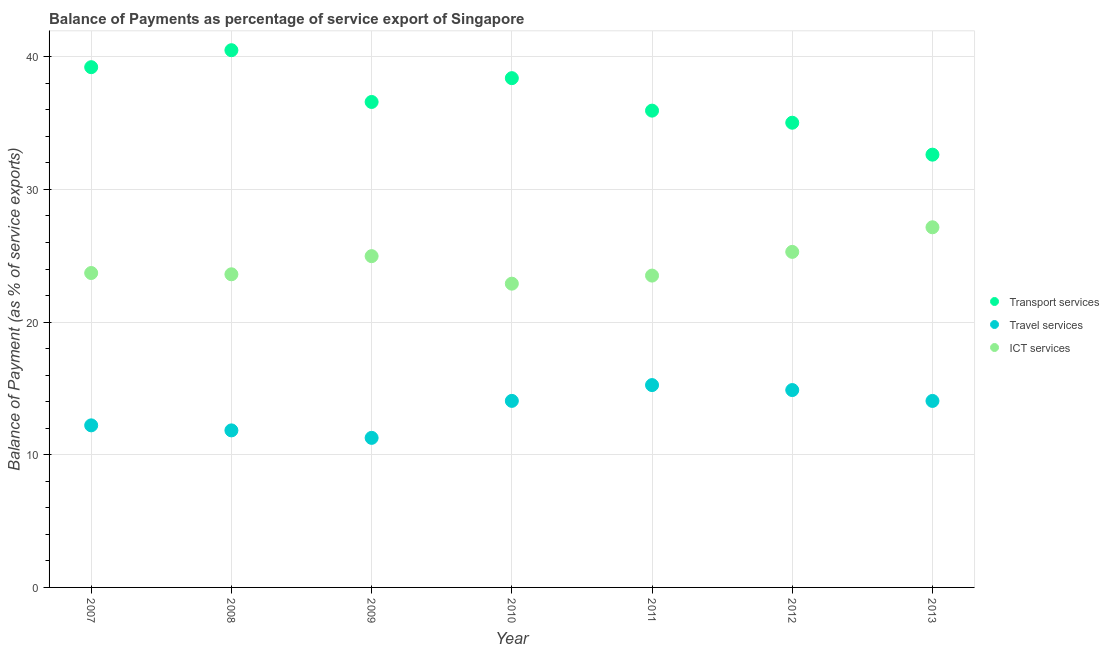How many different coloured dotlines are there?
Offer a terse response. 3. What is the balance of payment of travel services in 2010?
Provide a short and direct response. 14.06. Across all years, what is the maximum balance of payment of transport services?
Offer a very short reply. 40.49. Across all years, what is the minimum balance of payment of transport services?
Provide a succinct answer. 32.62. In which year was the balance of payment of travel services maximum?
Your answer should be very brief. 2011. What is the total balance of payment of travel services in the graph?
Your answer should be very brief. 93.57. What is the difference between the balance of payment of ict services in 2007 and that in 2013?
Provide a succinct answer. -3.45. What is the difference between the balance of payment of travel services in 2007 and the balance of payment of transport services in 2012?
Offer a terse response. -22.81. What is the average balance of payment of travel services per year?
Give a very brief answer. 13.37. In the year 2007, what is the difference between the balance of payment of transport services and balance of payment of ict services?
Provide a succinct answer. 15.52. What is the ratio of the balance of payment of travel services in 2007 to that in 2008?
Keep it short and to the point. 1.03. What is the difference between the highest and the second highest balance of payment of travel services?
Provide a short and direct response. 0.38. What is the difference between the highest and the lowest balance of payment of travel services?
Offer a terse response. 3.98. In how many years, is the balance of payment of ict services greater than the average balance of payment of ict services taken over all years?
Provide a short and direct response. 3. Is the sum of the balance of payment of transport services in 2007 and 2013 greater than the maximum balance of payment of travel services across all years?
Your response must be concise. Yes. Is the balance of payment of travel services strictly greater than the balance of payment of transport services over the years?
Keep it short and to the point. No. How many dotlines are there?
Your answer should be very brief. 3. Are the values on the major ticks of Y-axis written in scientific E-notation?
Give a very brief answer. No. Does the graph contain grids?
Ensure brevity in your answer.  Yes. How many legend labels are there?
Keep it short and to the point. 3. How are the legend labels stacked?
Offer a terse response. Vertical. What is the title of the graph?
Provide a succinct answer. Balance of Payments as percentage of service export of Singapore. What is the label or title of the Y-axis?
Ensure brevity in your answer.  Balance of Payment (as % of service exports). What is the Balance of Payment (as % of service exports) in Transport services in 2007?
Keep it short and to the point. 39.21. What is the Balance of Payment (as % of service exports) of Travel services in 2007?
Provide a succinct answer. 12.22. What is the Balance of Payment (as % of service exports) of ICT services in 2007?
Your response must be concise. 23.7. What is the Balance of Payment (as % of service exports) of Transport services in 2008?
Your answer should be compact. 40.49. What is the Balance of Payment (as % of service exports) in Travel services in 2008?
Offer a very short reply. 11.84. What is the Balance of Payment (as % of service exports) in ICT services in 2008?
Provide a succinct answer. 23.6. What is the Balance of Payment (as % of service exports) of Transport services in 2009?
Keep it short and to the point. 36.59. What is the Balance of Payment (as % of service exports) in Travel services in 2009?
Provide a short and direct response. 11.27. What is the Balance of Payment (as % of service exports) in ICT services in 2009?
Provide a short and direct response. 24.97. What is the Balance of Payment (as % of service exports) of Transport services in 2010?
Your answer should be very brief. 38.39. What is the Balance of Payment (as % of service exports) in Travel services in 2010?
Your answer should be compact. 14.06. What is the Balance of Payment (as % of service exports) in ICT services in 2010?
Provide a short and direct response. 22.9. What is the Balance of Payment (as % of service exports) of Transport services in 2011?
Your response must be concise. 35.94. What is the Balance of Payment (as % of service exports) of Travel services in 2011?
Offer a terse response. 15.25. What is the Balance of Payment (as % of service exports) in ICT services in 2011?
Provide a succinct answer. 23.5. What is the Balance of Payment (as % of service exports) of Transport services in 2012?
Your answer should be compact. 35.03. What is the Balance of Payment (as % of service exports) of Travel services in 2012?
Provide a short and direct response. 14.88. What is the Balance of Payment (as % of service exports) of ICT services in 2012?
Your response must be concise. 25.29. What is the Balance of Payment (as % of service exports) in Transport services in 2013?
Ensure brevity in your answer.  32.62. What is the Balance of Payment (as % of service exports) in Travel services in 2013?
Provide a short and direct response. 14.06. What is the Balance of Payment (as % of service exports) in ICT services in 2013?
Make the answer very short. 27.15. Across all years, what is the maximum Balance of Payment (as % of service exports) in Transport services?
Keep it short and to the point. 40.49. Across all years, what is the maximum Balance of Payment (as % of service exports) of Travel services?
Provide a succinct answer. 15.25. Across all years, what is the maximum Balance of Payment (as % of service exports) of ICT services?
Keep it short and to the point. 27.15. Across all years, what is the minimum Balance of Payment (as % of service exports) of Transport services?
Provide a succinct answer. 32.62. Across all years, what is the minimum Balance of Payment (as % of service exports) in Travel services?
Your response must be concise. 11.27. Across all years, what is the minimum Balance of Payment (as % of service exports) in ICT services?
Offer a very short reply. 22.9. What is the total Balance of Payment (as % of service exports) in Transport services in the graph?
Provide a succinct answer. 258.27. What is the total Balance of Payment (as % of service exports) in Travel services in the graph?
Make the answer very short. 93.57. What is the total Balance of Payment (as % of service exports) of ICT services in the graph?
Offer a very short reply. 171.11. What is the difference between the Balance of Payment (as % of service exports) of Transport services in 2007 and that in 2008?
Provide a short and direct response. -1.28. What is the difference between the Balance of Payment (as % of service exports) of Travel services in 2007 and that in 2008?
Keep it short and to the point. 0.38. What is the difference between the Balance of Payment (as % of service exports) of ICT services in 2007 and that in 2008?
Your response must be concise. 0.1. What is the difference between the Balance of Payment (as % of service exports) of Transport services in 2007 and that in 2009?
Your answer should be very brief. 2.62. What is the difference between the Balance of Payment (as % of service exports) in Travel services in 2007 and that in 2009?
Ensure brevity in your answer.  0.94. What is the difference between the Balance of Payment (as % of service exports) in ICT services in 2007 and that in 2009?
Offer a terse response. -1.27. What is the difference between the Balance of Payment (as % of service exports) of Transport services in 2007 and that in 2010?
Your answer should be compact. 0.83. What is the difference between the Balance of Payment (as % of service exports) of Travel services in 2007 and that in 2010?
Offer a very short reply. -1.84. What is the difference between the Balance of Payment (as % of service exports) of ICT services in 2007 and that in 2010?
Provide a succinct answer. 0.8. What is the difference between the Balance of Payment (as % of service exports) of Transport services in 2007 and that in 2011?
Offer a terse response. 3.28. What is the difference between the Balance of Payment (as % of service exports) of Travel services in 2007 and that in 2011?
Offer a terse response. -3.04. What is the difference between the Balance of Payment (as % of service exports) of ICT services in 2007 and that in 2011?
Your answer should be very brief. 0.19. What is the difference between the Balance of Payment (as % of service exports) of Transport services in 2007 and that in 2012?
Offer a very short reply. 4.19. What is the difference between the Balance of Payment (as % of service exports) of Travel services in 2007 and that in 2012?
Provide a succinct answer. -2.66. What is the difference between the Balance of Payment (as % of service exports) in ICT services in 2007 and that in 2012?
Your answer should be very brief. -1.59. What is the difference between the Balance of Payment (as % of service exports) in Transport services in 2007 and that in 2013?
Your answer should be compact. 6.59. What is the difference between the Balance of Payment (as % of service exports) of Travel services in 2007 and that in 2013?
Provide a short and direct response. -1.84. What is the difference between the Balance of Payment (as % of service exports) of ICT services in 2007 and that in 2013?
Your response must be concise. -3.45. What is the difference between the Balance of Payment (as % of service exports) of Transport services in 2008 and that in 2009?
Ensure brevity in your answer.  3.9. What is the difference between the Balance of Payment (as % of service exports) in Travel services in 2008 and that in 2009?
Ensure brevity in your answer.  0.56. What is the difference between the Balance of Payment (as % of service exports) in ICT services in 2008 and that in 2009?
Your answer should be very brief. -1.37. What is the difference between the Balance of Payment (as % of service exports) in Transport services in 2008 and that in 2010?
Offer a terse response. 2.11. What is the difference between the Balance of Payment (as % of service exports) of Travel services in 2008 and that in 2010?
Give a very brief answer. -2.22. What is the difference between the Balance of Payment (as % of service exports) in ICT services in 2008 and that in 2010?
Keep it short and to the point. 0.71. What is the difference between the Balance of Payment (as % of service exports) in Transport services in 2008 and that in 2011?
Offer a terse response. 4.55. What is the difference between the Balance of Payment (as % of service exports) in Travel services in 2008 and that in 2011?
Ensure brevity in your answer.  -3.42. What is the difference between the Balance of Payment (as % of service exports) in ICT services in 2008 and that in 2011?
Your answer should be very brief. 0.1. What is the difference between the Balance of Payment (as % of service exports) in Transport services in 2008 and that in 2012?
Ensure brevity in your answer.  5.47. What is the difference between the Balance of Payment (as % of service exports) of Travel services in 2008 and that in 2012?
Make the answer very short. -3.04. What is the difference between the Balance of Payment (as % of service exports) in ICT services in 2008 and that in 2012?
Keep it short and to the point. -1.69. What is the difference between the Balance of Payment (as % of service exports) of Transport services in 2008 and that in 2013?
Provide a short and direct response. 7.87. What is the difference between the Balance of Payment (as % of service exports) of Travel services in 2008 and that in 2013?
Your answer should be compact. -2.22. What is the difference between the Balance of Payment (as % of service exports) of ICT services in 2008 and that in 2013?
Offer a terse response. -3.54. What is the difference between the Balance of Payment (as % of service exports) in Transport services in 2009 and that in 2010?
Give a very brief answer. -1.79. What is the difference between the Balance of Payment (as % of service exports) in Travel services in 2009 and that in 2010?
Provide a short and direct response. -2.79. What is the difference between the Balance of Payment (as % of service exports) of ICT services in 2009 and that in 2010?
Your answer should be compact. 2.07. What is the difference between the Balance of Payment (as % of service exports) of Transport services in 2009 and that in 2011?
Ensure brevity in your answer.  0.65. What is the difference between the Balance of Payment (as % of service exports) of Travel services in 2009 and that in 2011?
Keep it short and to the point. -3.98. What is the difference between the Balance of Payment (as % of service exports) of ICT services in 2009 and that in 2011?
Your answer should be very brief. 1.47. What is the difference between the Balance of Payment (as % of service exports) in Transport services in 2009 and that in 2012?
Your answer should be very brief. 1.57. What is the difference between the Balance of Payment (as % of service exports) in Travel services in 2009 and that in 2012?
Offer a terse response. -3.6. What is the difference between the Balance of Payment (as % of service exports) in ICT services in 2009 and that in 2012?
Keep it short and to the point. -0.32. What is the difference between the Balance of Payment (as % of service exports) in Transport services in 2009 and that in 2013?
Your answer should be very brief. 3.97. What is the difference between the Balance of Payment (as % of service exports) of Travel services in 2009 and that in 2013?
Offer a terse response. -2.78. What is the difference between the Balance of Payment (as % of service exports) of ICT services in 2009 and that in 2013?
Make the answer very short. -2.18. What is the difference between the Balance of Payment (as % of service exports) of Transport services in 2010 and that in 2011?
Give a very brief answer. 2.45. What is the difference between the Balance of Payment (as % of service exports) of Travel services in 2010 and that in 2011?
Keep it short and to the point. -1.19. What is the difference between the Balance of Payment (as % of service exports) in ICT services in 2010 and that in 2011?
Offer a very short reply. -0.61. What is the difference between the Balance of Payment (as % of service exports) of Transport services in 2010 and that in 2012?
Offer a very short reply. 3.36. What is the difference between the Balance of Payment (as % of service exports) of Travel services in 2010 and that in 2012?
Your answer should be very brief. -0.82. What is the difference between the Balance of Payment (as % of service exports) of ICT services in 2010 and that in 2012?
Make the answer very short. -2.4. What is the difference between the Balance of Payment (as % of service exports) in Transport services in 2010 and that in 2013?
Keep it short and to the point. 5.77. What is the difference between the Balance of Payment (as % of service exports) in Travel services in 2010 and that in 2013?
Your answer should be compact. 0. What is the difference between the Balance of Payment (as % of service exports) of ICT services in 2010 and that in 2013?
Give a very brief answer. -4.25. What is the difference between the Balance of Payment (as % of service exports) of Transport services in 2011 and that in 2012?
Offer a terse response. 0.91. What is the difference between the Balance of Payment (as % of service exports) in Travel services in 2011 and that in 2012?
Give a very brief answer. 0.38. What is the difference between the Balance of Payment (as % of service exports) in ICT services in 2011 and that in 2012?
Your response must be concise. -1.79. What is the difference between the Balance of Payment (as % of service exports) in Transport services in 2011 and that in 2013?
Your answer should be compact. 3.32. What is the difference between the Balance of Payment (as % of service exports) of Travel services in 2011 and that in 2013?
Your answer should be very brief. 1.19. What is the difference between the Balance of Payment (as % of service exports) in ICT services in 2011 and that in 2013?
Provide a succinct answer. -3.64. What is the difference between the Balance of Payment (as % of service exports) of Transport services in 2012 and that in 2013?
Provide a short and direct response. 2.41. What is the difference between the Balance of Payment (as % of service exports) in Travel services in 2012 and that in 2013?
Make the answer very short. 0.82. What is the difference between the Balance of Payment (as % of service exports) in ICT services in 2012 and that in 2013?
Offer a very short reply. -1.85. What is the difference between the Balance of Payment (as % of service exports) in Transport services in 2007 and the Balance of Payment (as % of service exports) in Travel services in 2008?
Offer a very short reply. 27.38. What is the difference between the Balance of Payment (as % of service exports) in Transport services in 2007 and the Balance of Payment (as % of service exports) in ICT services in 2008?
Make the answer very short. 15.61. What is the difference between the Balance of Payment (as % of service exports) of Travel services in 2007 and the Balance of Payment (as % of service exports) of ICT services in 2008?
Offer a very short reply. -11.39. What is the difference between the Balance of Payment (as % of service exports) of Transport services in 2007 and the Balance of Payment (as % of service exports) of Travel services in 2009?
Give a very brief answer. 27.94. What is the difference between the Balance of Payment (as % of service exports) in Transport services in 2007 and the Balance of Payment (as % of service exports) in ICT services in 2009?
Offer a terse response. 14.24. What is the difference between the Balance of Payment (as % of service exports) of Travel services in 2007 and the Balance of Payment (as % of service exports) of ICT services in 2009?
Provide a short and direct response. -12.75. What is the difference between the Balance of Payment (as % of service exports) of Transport services in 2007 and the Balance of Payment (as % of service exports) of Travel services in 2010?
Give a very brief answer. 25.15. What is the difference between the Balance of Payment (as % of service exports) in Transport services in 2007 and the Balance of Payment (as % of service exports) in ICT services in 2010?
Your response must be concise. 16.32. What is the difference between the Balance of Payment (as % of service exports) in Travel services in 2007 and the Balance of Payment (as % of service exports) in ICT services in 2010?
Give a very brief answer. -10.68. What is the difference between the Balance of Payment (as % of service exports) in Transport services in 2007 and the Balance of Payment (as % of service exports) in Travel services in 2011?
Your answer should be compact. 23.96. What is the difference between the Balance of Payment (as % of service exports) of Transport services in 2007 and the Balance of Payment (as % of service exports) of ICT services in 2011?
Your response must be concise. 15.71. What is the difference between the Balance of Payment (as % of service exports) of Travel services in 2007 and the Balance of Payment (as % of service exports) of ICT services in 2011?
Offer a terse response. -11.29. What is the difference between the Balance of Payment (as % of service exports) of Transport services in 2007 and the Balance of Payment (as % of service exports) of Travel services in 2012?
Keep it short and to the point. 24.34. What is the difference between the Balance of Payment (as % of service exports) of Transport services in 2007 and the Balance of Payment (as % of service exports) of ICT services in 2012?
Offer a terse response. 13.92. What is the difference between the Balance of Payment (as % of service exports) of Travel services in 2007 and the Balance of Payment (as % of service exports) of ICT services in 2012?
Your answer should be compact. -13.08. What is the difference between the Balance of Payment (as % of service exports) in Transport services in 2007 and the Balance of Payment (as % of service exports) in Travel services in 2013?
Give a very brief answer. 25.16. What is the difference between the Balance of Payment (as % of service exports) of Transport services in 2007 and the Balance of Payment (as % of service exports) of ICT services in 2013?
Your answer should be compact. 12.07. What is the difference between the Balance of Payment (as % of service exports) in Travel services in 2007 and the Balance of Payment (as % of service exports) in ICT services in 2013?
Ensure brevity in your answer.  -14.93. What is the difference between the Balance of Payment (as % of service exports) in Transport services in 2008 and the Balance of Payment (as % of service exports) in Travel services in 2009?
Your answer should be compact. 29.22. What is the difference between the Balance of Payment (as % of service exports) in Transport services in 2008 and the Balance of Payment (as % of service exports) in ICT services in 2009?
Your answer should be compact. 15.52. What is the difference between the Balance of Payment (as % of service exports) of Travel services in 2008 and the Balance of Payment (as % of service exports) of ICT services in 2009?
Your answer should be very brief. -13.13. What is the difference between the Balance of Payment (as % of service exports) of Transport services in 2008 and the Balance of Payment (as % of service exports) of Travel services in 2010?
Your answer should be compact. 26.43. What is the difference between the Balance of Payment (as % of service exports) of Transport services in 2008 and the Balance of Payment (as % of service exports) of ICT services in 2010?
Provide a short and direct response. 17.6. What is the difference between the Balance of Payment (as % of service exports) of Travel services in 2008 and the Balance of Payment (as % of service exports) of ICT services in 2010?
Keep it short and to the point. -11.06. What is the difference between the Balance of Payment (as % of service exports) in Transport services in 2008 and the Balance of Payment (as % of service exports) in Travel services in 2011?
Make the answer very short. 25.24. What is the difference between the Balance of Payment (as % of service exports) of Transport services in 2008 and the Balance of Payment (as % of service exports) of ICT services in 2011?
Keep it short and to the point. 16.99. What is the difference between the Balance of Payment (as % of service exports) of Travel services in 2008 and the Balance of Payment (as % of service exports) of ICT services in 2011?
Provide a short and direct response. -11.67. What is the difference between the Balance of Payment (as % of service exports) in Transport services in 2008 and the Balance of Payment (as % of service exports) in Travel services in 2012?
Provide a short and direct response. 25.62. What is the difference between the Balance of Payment (as % of service exports) of Transport services in 2008 and the Balance of Payment (as % of service exports) of ICT services in 2012?
Your answer should be compact. 15.2. What is the difference between the Balance of Payment (as % of service exports) in Travel services in 2008 and the Balance of Payment (as % of service exports) in ICT services in 2012?
Provide a short and direct response. -13.45. What is the difference between the Balance of Payment (as % of service exports) of Transport services in 2008 and the Balance of Payment (as % of service exports) of Travel services in 2013?
Provide a short and direct response. 26.44. What is the difference between the Balance of Payment (as % of service exports) in Transport services in 2008 and the Balance of Payment (as % of service exports) in ICT services in 2013?
Offer a terse response. 13.35. What is the difference between the Balance of Payment (as % of service exports) of Travel services in 2008 and the Balance of Payment (as % of service exports) of ICT services in 2013?
Keep it short and to the point. -15.31. What is the difference between the Balance of Payment (as % of service exports) of Transport services in 2009 and the Balance of Payment (as % of service exports) of Travel services in 2010?
Offer a very short reply. 22.53. What is the difference between the Balance of Payment (as % of service exports) in Transport services in 2009 and the Balance of Payment (as % of service exports) in ICT services in 2010?
Keep it short and to the point. 13.7. What is the difference between the Balance of Payment (as % of service exports) of Travel services in 2009 and the Balance of Payment (as % of service exports) of ICT services in 2010?
Provide a succinct answer. -11.62. What is the difference between the Balance of Payment (as % of service exports) of Transport services in 2009 and the Balance of Payment (as % of service exports) of Travel services in 2011?
Ensure brevity in your answer.  21.34. What is the difference between the Balance of Payment (as % of service exports) in Transport services in 2009 and the Balance of Payment (as % of service exports) in ICT services in 2011?
Your answer should be compact. 13.09. What is the difference between the Balance of Payment (as % of service exports) of Travel services in 2009 and the Balance of Payment (as % of service exports) of ICT services in 2011?
Give a very brief answer. -12.23. What is the difference between the Balance of Payment (as % of service exports) of Transport services in 2009 and the Balance of Payment (as % of service exports) of Travel services in 2012?
Ensure brevity in your answer.  21.72. What is the difference between the Balance of Payment (as % of service exports) of Transport services in 2009 and the Balance of Payment (as % of service exports) of ICT services in 2012?
Your answer should be very brief. 11.3. What is the difference between the Balance of Payment (as % of service exports) in Travel services in 2009 and the Balance of Payment (as % of service exports) in ICT services in 2012?
Offer a terse response. -14.02. What is the difference between the Balance of Payment (as % of service exports) in Transport services in 2009 and the Balance of Payment (as % of service exports) in Travel services in 2013?
Offer a very short reply. 22.53. What is the difference between the Balance of Payment (as % of service exports) in Transport services in 2009 and the Balance of Payment (as % of service exports) in ICT services in 2013?
Your response must be concise. 9.45. What is the difference between the Balance of Payment (as % of service exports) in Travel services in 2009 and the Balance of Payment (as % of service exports) in ICT services in 2013?
Offer a terse response. -15.87. What is the difference between the Balance of Payment (as % of service exports) in Transport services in 2010 and the Balance of Payment (as % of service exports) in Travel services in 2011?
Provide a succinct answer. 23.13. What is the difference between the Balance of Payment (as % of service exports) of Transport services in 2010 and the Balance of Payment (as % of service exports) of ICT services in 2011?
Your response must be concise. 14.88. What is the difference between the Balance of Payment (as % of service exports) of Travel services in 2010 and the Balance of Payment (as % of service exports) of ICT services in 2011?
Your answer should be very brief. -9.44. What is the difference between the Balance of Payment (as % of service exports) in Transport services in 2010 and the Balance of Payment (as % of service exports) in Travel services in 2012?
Your answer should be very brief. 23.51. What is the difference between the Balance of Payment (as % of service exports) of Transport services in 2010 and the Balance of Payment (as % of service exports) of ICT services in 2012?
Make the answer very short. 13.09. What is the difference between the Balance of Payment (as % of service exports) of Travel services in 2010 and the Balance of Payment (as % of service exports) of ICT services in 2012?
Provide a short and direct response. -11.23. What is the difference between the Balance of Payment (as % of service exports) of Transport services in 2010 and the Balance of Payment (as % of service exports) of Travel services in 2013?
Ensure brevity in your answer.  24.33. What is the difference between the Balance of Payment (as % of service exports) in Transport services in 2010 and the Balance of Payment (as % of service exports) in ICT services in 2013?
Provide a short and direct response. 11.24. What is the difference between the Balance of Payment (as % of service exports) in Travel services in 2010 and the Balance of Payment (as % of service exports) in ICT services in 2013?
Ensure brevity in your answer.  -13.09. What is the difference between the Balance of Payment (as % of service exports) of Transport services in 2011 and the Balance of Payment (as % of service exports) of Travel services in 2012?
Give a very brief answer. 21.06. What is the difference between the Balance of Payment (as % of service exports) of Transport services in 2011 and the Balance of Payment (as % of service exports) of ICT services in 2012?
Offer a terse response. 10.65. What is the difference between the Balance of Payment (as % of service exports) of Travel services in 2011 and the Balance of Payment (as % of service exports) of ICT services in 2012?
Your answer should be very brief. -10.04. What is the difference between the Balance of Payment (as % of service exports) of Transport services in 2011 and the Balance of Payment (as % of service exports) of Travel services in 2013?
Provide a short and direct response. 21.88. What is the difference between the Balance of Payment (as % of service exports) in Transport services in 2011 and the Balance of Payment (as % of service exports) in ICT services in 2013?
Your response must be concise. 8.79. What is the difference between the Balance of Payment (as % of service exports) of Travel services in 2011 and the Balance of Payment (as % of service exports) of ICT services in 2013?
Make the answer very short. -11.89. What is the difference between the Balance of Payment (as % of service exports) of Transport services in 2012 and the Balance of Payment (as % of service exports) of Travel services in 2013?
Provide a succinct answer. 20.97. What is the difference between the Balance of Payment (as % of service exports) of Transport services in 2012 and the Balance of Payment (as % of service exports) of ICT services in 2013?
Provide a succinct answer. 7.88. What is the difference between the Balance of Payment (as % of service exports) of Travel services in 2012 and the Balance of Payment (as % of service exports) of ICT services in 2013?
Ensure brevity in your answer.  -12.27. What is the average Balance of Payment (as % of service exports) of Transport services per year?
Your response must be concise. 36.9. What is the average Balance of Payment (as % of service exports) of Travel services per year?
Offer a very short reply. 13.37. What is the average Balance of Payment (as % of service exports) in ICT services per year?
Offer a very short reply. 24.44. In the year 2007, what is the difference between the Balance of Payment (as % of service exports) in Transport services and Balance of Payment (as % of service exports) in Travel services?
Provide a short and direct response. 27. In the year 2007, what is the difference between the Balance of Payment (as % of service exports) in Transport services and Balance of Payment (as % of service exports) in ICT services?
Ensure brevity in your answer.  15.52. In the year 2007, what is the difference between the Balance of Payment (as % of service exports) in Travel services and Balance of Payment (as % of service exports) in ICT services?
Provide a succinct answer. -11.48. In the year 2008, what is the difference between the Balance of Payment (as % of service exports) in Transport services and Balance of Payment (as % of service exports) in Travel services?
Keep it short and to the point. 28.66. In the year 2008, what is the difference between the Balance of Payment (as % of service exports) of Transport services and Balance of Payment (as % of service exports) of ICT services?
Make the answer very short. 16.89. In the year 2008, what is the difference between the Balance of Payment (as % of service exports) of Travel services and Balance of Payment (as % of service exports) of ICT services?
Your answer should be very brief. -11.77. In the year 2009, what is the difference between the Balance of Payment (as % of service exports) of Transport services and Balance of Payment (as % of service exports) of Travel services?
Offer a terse response. 25.32. In the year 2009, what is the difference between the Balance of Payment (as % of service exports) in Transport services and Balance of Payment (as % of service exports) in ICT services?
Provide a short and direct response. 11.62. In the year 2009, what is the difference between the Balance of Payment (as % of service exports) in Travel services and Balance of Payment (as % of service exports) in ICT services?
Your response must be concise. -13.7. In the year 2010, what is the difference between the Balance of Payment (as % of service exports) of Transport services and Balance of Payment (as % of service exports) of Travel services?
Your answer should be compact. 24.33. In the year 2010, what is the difference between the Balance of Payment (as % of service exports) in Transport services and Balance of Payment (as % of service exports) in ICT services?
Make the answer very short. 15.49. In the year 2010, what is the difference between the Balance of Payment (as % of service exports) of Travel services and Balance of Payment (as % of service exports) of ICT services?
Provide a short and direct response. -8.84. In the year 2011, what is the difference between the Balance of Payment (as % of service exports) of Transport services and Balance of Payment (as % of service exports) of Travel services?
Offer a very short reply. 20.69. In the year 2011, what is the difference between the Balance of Payment (as % of service exports) of Transport services and Balance of Payment (as % of service exports) of ICT services?
Offer a very short reply. 12.43. In the year 2011, what is the difference between the Balance of Payment (as % of service exports) of Travel services and Balance of Payment (as % of service exports) of ICT services?
Offer a terse response. -8.25. In the year 2012, what is the difference between the Balance of Payment (as % of service exports) in Transport services and Balance of Payment (as % of service exports) in Travel services?
Make the answer very short. 20.15. In the year 2012, what is the difference between the Balance of Payment (as % of service exports) of Transport services and Balance of Payment (as % of service exports) of ICT services?
Your answer should be very brief. 9.73. In the year 2012, what is the difference between the Balance of Payment (as % of service exports) of Travel services and Balance of Payment (as % of service exports) of ICT services?
Offer a very short reply. -10.42. In the year 2013, what is the difference between the Balance of Payment (as % of service exports) of Transport services and Balance of Payment (as % of service exports) of Travel services?
Make the answer very short. 18.56. In the year 2013, what is the difference between the Balance of Payment (as % of service exports) in Transport services and Balance of Payment (as % of service exports) in ICT services?
Ensure brevity in your answer.  5.47. In the year 2013, what is the difference between the Balance of Payment (as % of service exports) in Travel services and Balance of Payment (as % of service exports) in ICT services?
Provide a succinct answer. -13.09. What is the ratio of the Balance of Payment (as % of service exports) of Transport services in 2007 to that in 2008?
Provide a succinct answer. 0.97. What is the ratio of the Balance of Payment (as % of service exports) of Travel services in 2007 to that in 2008?
Your answer should be compact. 1.03. What is the ratio of the Balance of Payment (as % of service exports) in Transport services in 2007 to that in 2009?
Give a very brief answer. 1.07. What is the ratio of the Balance of Payment (as % of service exports) in Travel services in 2007 to that in 2009?
Ensure brevity in your answer.  1.08. What is the ratio of the Balance of Payment (as % of service exports) in ICT services in 2007 to that in 2009?
Offer a very short reply. 0.95. What is the ratio of the Balance of Payment (as % of service exports) in Transport services in 2007 to that in 2010?
Give a very brief answer. 1.02. What is the ratio of the Balance of Payment (as % of service exports) in Travel services in 2007 to that in 2010?
Keep it short and to the point. 0.87. What is the ratio of the Balance of Payment (as % of service exports) in ICT services in 2007 to that in 2010?
Offer a terse response. 1.04. What is the ratio of the Balance of Payment (as % of service exports) of Transport services in 2007 to that in 2011?
Provide a succinct answer. 1.09. What is the ratio of the Balance of Payment (as % of service exports) of Travel services in 2007 to that in 2011?
Make the answer very short. 0.8. What is the ratio of the Balance of Payment (as % of service exports) in ICT services in 2007 to that in 2011?
Make the answer very short. 1.01. What is the ratio of the Balance of Payment (as % of service exports) of Transport services in 2007 to that in 2012?
Offer a terse response. 1.12. What is the ratio of the Balance of Payment (as % of service exports) of Travel services in 2007 to that in 2012?
Ensure brevity in your answer.  0.82. What is the ratio of the Balance of Payment (as % of service exports) in ICT services in 2007 to that in 2012?
Offer a terse response. 0.94. What is the ratio of the Balance of Payment (as % of service exports) in Transport services in 2007 to that in 2013?
Your answer should be compact. 1.2. What is the ratio of the Balance of Payment (as % of service exports) of Travel services in 2007 to that in 2013?
Your response must be concise. 0.87. What is the ratio of the Balance of Payment (as % of service exports) of ICT services in 2007 to that in 2013?
Your answer should be compact. 0.87. What is the ratio of the Balance of Payment (as % of service exports) in Transport services in 2008 to that in 2009?
Your answer should be very brief. 1.11. What is the ratio of the Balance of Payment (as % of service exports) of Travel services in 2008 to that in 2009?
Your answer should be compact. 1.05. What is the ratio of the Balance of Payment (as % of service exports) in ICT services in 2008 to that in 2009?
Give a very brief answer. 0.95. What is the ratio of the Balance of Payment (as % of service exports) in Transport services in 2008 to that in 2010?
Your answer should be compact. 1.05. What is the ratio of the Balance of Payment (as % of service exports) of Travel services in 2008 to that in 2010?
Give a very brief answer. 0.84. What is the ratio of the Balance of Payment (as % of service exports) of ICT services in 2008 to that in 2010?
Offer a very short reply. 1.03. What is the ratio of the Balance of Payment (as % of service exports) of Transport services in 2008 to that in 2011?
Offer a very short reply. 1.13. What is the ratio of the Balance of Payment (as % of service exports) of Travel services in 2008 to that in 2011?
Keep it short and to the point. 0.78. What is the ratio of the Balance of Payment (as % of service exports) in Transport services in 2008 to that in 2012?
Your answer should be compact. 1.16. What is the ratio of the Balance of Payment (as % of service exports) in Travel services in 2008 to that in 2012?
Your answer should be very brief. 0.8. What is the ratio of the Balance of Payment (as % of service exports) of ICT services in 2008 to that in 2012?
Give a very brief answer. 0.93. What is the ratio of the Balance of Payment (as % of service exports) of Transport services in 2008 to that in 2013?
Provide a short and direct response. 1.24. What is the ratio of the Balance of Payment (as % of service exports) of Travel services in 2008 to that in 2013?
Offer a terse response. 0.84. What is the ratio of the Balance of Payment (as % of service exports) in ICT services in 2008 to that in 2013?
Provide a short and direct response. 0.87. What is the ratio of the Balance of Payment (as % of service exports) in Transport services in 2009 to that in 2010?
Offer a very short reply. 0.95. What is the ratio of the Balance of Payment (as % of service exports) in Travel services in 2009 to that in 2010?
Make the answer very short. 0.8. What is the ratio of the Balance of Payment (as % of service exports) of ICT services in 2009 to that in 2010?
Keep it short and to the point. 1.09. What is the ratio of the Balance of Payment (as % of service exports) in Transport services in 2009 to that in 2011?
Offer a very short reply. 1.02. What is the ratio of the Balance of Payment (as % of service exports) of Travel services in 2009 to that in 2011?
Keep it short and to the point. 0.74. What is the ratio of the Balance of Payment (as % of service exports) of ICT services in 2009 to that in 2011?
Offer a terse response. 1.06. What is the ratio of the Balance of Payment (as % of service exports) of Transport services in 2009 to that in 2012?
Give a very brief answer. 1.04. What is the ratio of the Balance of Payment (as % of service exports) of Travel services in 2009 to that in 2012?
Offer a terse response. 0.76. What is the ratio of the Balance of Payment (as % of service exports) of ICT services in 2009 to that in 2012?
Offer a terse response. 0.99. What is the ratio of the Balance of Payment (as % of service exports) in Transport services in 2009 to that in 2013?
Provide a short and direct response. 1.12. What is the ratio of the Balance of Payment (as % of service exports) in Travel services in 2009 to that in 2013?
Offer a terse response. 0.8. What is the ratio of the Balance of Payment (as % of service exports) of ICT services in 2009 to that in 2013?
Make the answer very short. 0.92. What is the ratio of the Balance of Payment (as % of service exports) in Transport services in 2010 to that in 2011?
Offer a terse response. 1.07. What is the ratio of the Balance of Payment (as % of service exports) in Travel services in 2010 to that in 2011?
Your response must be concise. 0.92. What is the ratio of the Balance of Payment (as % of service exports) of ICT services in 2010 to that in 2011?
Offer a very short reply. 0.97. What is the ratio of the Balance of Payment (as % of service exports) in Transport services in 2010 to that in 2012?
Provide a succinct answer. 1.1. What is the ratio of the Balance of Payment (as % of service exports) of Travel services in 2010 to that in 2012?
Ensure brevity in your answer.  0.95. What is the ratio of the Balance of Payment (as % of service exports) of ICT services in 2010 to that in 2012?
Provide a succinct answer. 0.91. What is the ratio of the Balance of Payment (as % of service exports) of Transport services in 2010 to that in 2013?
Make the answer very short. 1.18. What is the ratio of the Balance of Payment (as % of service exports) of ICT services in 2010 to that in 2013?
Provide a short and direct response. 0.84. What is the ratio of the Balance of Payment (as % of service exports) of Travel services in 2011 to that in 2012?
Provide a succinct answer. 1.03. What is the ratio of the Balance of Payment (as % of service exports) of ICT services in 2011 to that in 2012?
Offer a very short reply. 0.93. What is the ratio of the Balance of Payment (as % of service exports) in Transport services in 2011 to that in 2013?
Your answer should be compact. 1.1. What is the ratio of the Balance of Payment (as % of service exports) of Travel services in 2011 to that in 2013?
Offer a very short reply. 1.08. What is the ratio of the Balance of Payment (as % of service exports) of ICT services in 2011 to that in 2013?
Your answer should be very brief. 0.87. What is the ratio of the Balance of Payment (as % of service exports) in Transport services in 2012 to that in 2013?
Make the answer very short. 1.07. What is the ratio of the Balance of Payment (as % of service exports) of Travel services in 2012 to that in 2013?
Your answer should be compact. 1.06. What is the ratio of the Balance of Payment (as % of service exports) in ICT services in 2012 to that in 2013?
Your response must be concise. 0.93. What is the difference between the highest and the second highest Balance of Payment (as % of service exports) in Transport services?
Your answer should be very brief. 1.28. What is the difference between the highest and the second highest Balance of Payment (as % of service exports) in Travel services?
Ensure brevity in your answer.  0.38. What is the difference between the highest and the second highest Balance of Payment (as % of service exports) in ICT services?
Make the answer very short. 1.85. What is the difference between the highest and the lowest Balance of Payment (as % of service exports) in Transport services?
Give a very brief answer. 7.87. What is the difference between the highest and the lowest Balance of Payment (as % of service exports) of Travel services?
Give a very brief answer. 3.98. What is the difference between the highest and the lowest Balance of Payment (as % of service exports) of ICT services?
Offer a terse response. 4.25. 